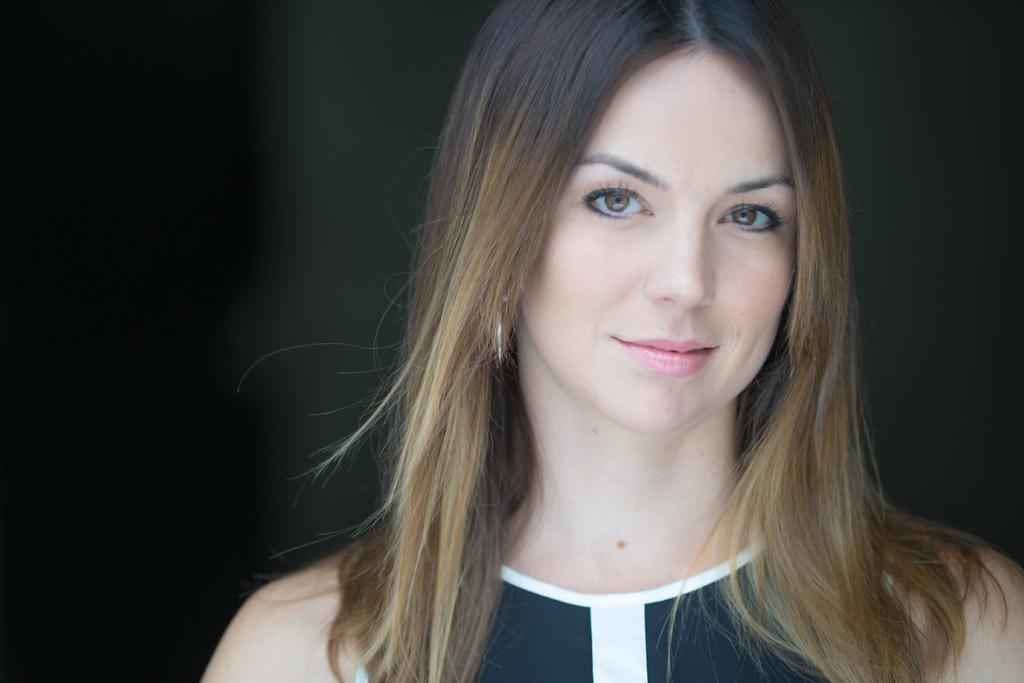Who is present in the image? There is a woman in the image. What is the woman's expression? The woman is smiling. What can be observed about the background of the image? The background of the image is dark. What type of wrench is the woman holding in the image? There is no wrench present in the image; the woman is not holding any tools. Is the woman playing a guitar in the image? There is no guitar present in the image; the woman is not depicted playing any musical instruments. 